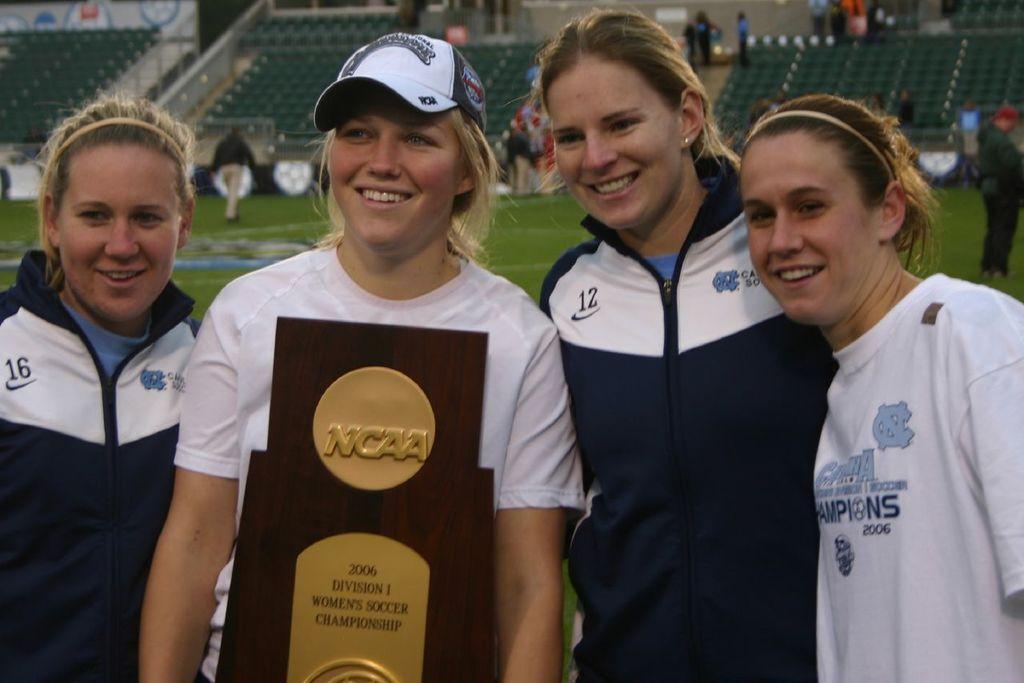Can you describe this image briefly? In the middle of the image few women are standing, smiling and she is holding a cup. Behind them few people are walking, standing and we can see stadium. 